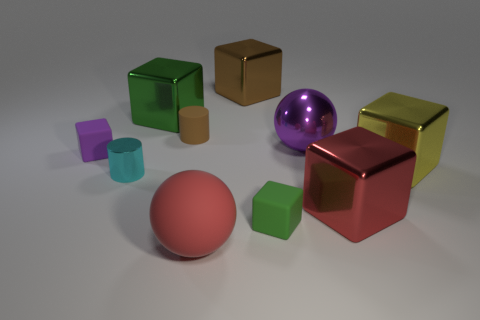Subtract all big cubes. How many cubes are left? 2 Subtract all brown cubes. How many cubes are left? 5 Subtract all blocks. How many objects are left? 4 Subtract all blue cylinders. How many red balls are left? 1 Add 6 big brown metal cubes. How many big brown metal cubes exist? 7 Subtract 1 purple balls. How many objects are left? 9 Subtract 5 blocks. How many blocks are left? 1 Subtract all yellow cylinders. Subtract all red cubes. How many cylinders are left? 2 Subtract all big red cubes. Subtract all large green things. How many objects are left? 8 Add 9 purple rubber things. How many purple rubber things are left? 10 